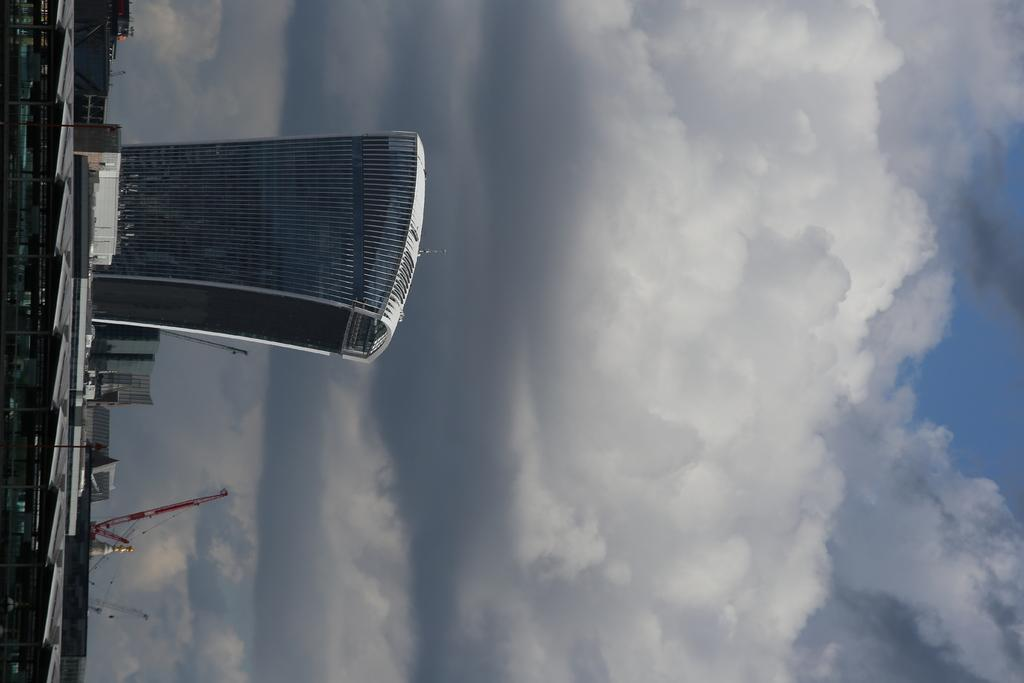What type of structures can be seen in the image? There are buildings in the image. What else can be seen besides the buildings? There are poles in the image. Can you describe the background of the image? The sky is visible in the background of the image. What other unspecified things can be seen in the image? There are other unspecified things in the image, but we cannot provide more details without additional information. How many crates are stacked on the ship in the image? There is no ship or crate present in the image. What type of tub is visible in the image? There is no tub present in the image. 